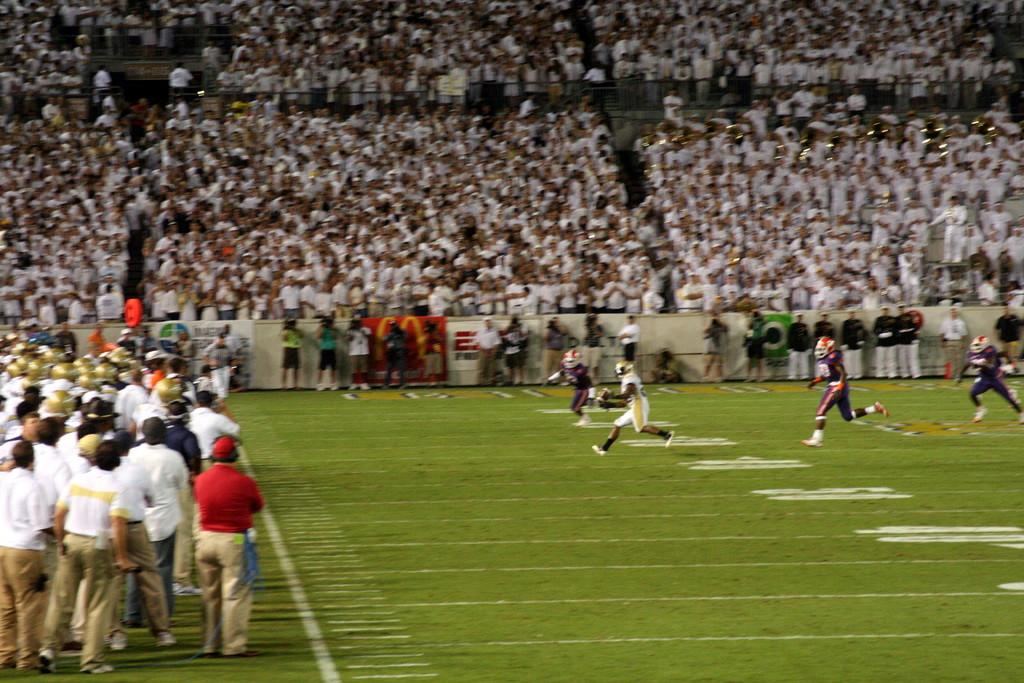What are the people in the image doing? There is a group of people standing on the ground. What can be seen in the background of the image? There are camera men and an audience in the background. What type of bean is being used as a prop by the people in the image? There is no bean present in the image. Is there a crook in the image trying to steal the camera equipment? There is no crook present in the image. 